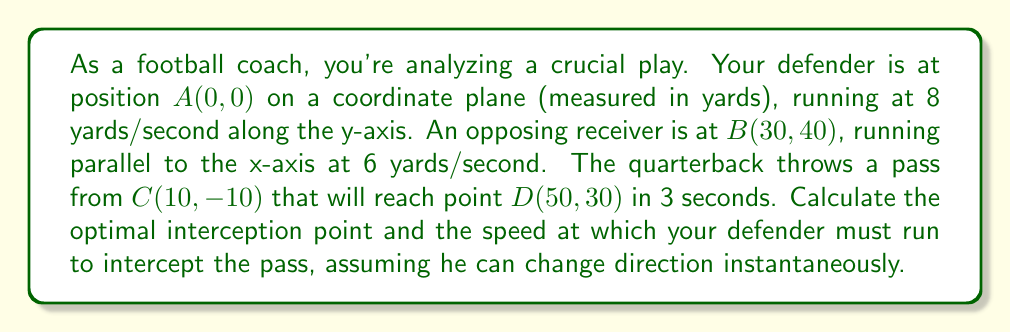Can you answer this question? Let's approach this step-by-step:

1) First, we need to find the receiver's position after 3 seconds:
   Initial position: $B(30, 40)$
   Velocity: 6 yards/second along x-axis
   New position after 3 seconds: $(30 + 6 * 3, 40) = (48, 40)$

2) The ball's trajectory is from $C(10, -10)$ to $D(50, 30)$ in 3 seconds.
   We can represent this as a vector:
   $$\vec{CD} = \langle 40, 40 \rangle$$

3) The ball's velocity vector (yards/second):
   $$\vec{v_{ball}} = \frac{\vec{CD}}{3} = \langle \frac{40}{3}, \frac{40}{3} \rangle$$

4) Now, let's parametrize the ball's position at time $t$:
   $$B(t) = (10 + \frac{40t}{3}, -10 + \frac{40t}{3})$$

5) Our defender's position at time $t$, if running at speed $s$:
   $$D(t) = (0, st)$$

6) For interception, these must be equal at some time $t$:
   $$10 + \frac{40t}{3} = 0$$
   $$-10 + \frac{40t}{3} = st$$

7) From the first equation:
   $$t = \frac{3}{4}$$

8) Substituting this into the second equation:
   $$-10 + \frac{40 * 3/4}{3} = s * \frac{3}{4}$$
   $$-10 + 10 = s * \frac{3}{4}$$
   $$s = 0$$

9) This result means our initial assumption was incorrect. The defender can't intercept by running straight along the y-axis.

10) Instead, let's find where the ball and receiver paths intersect:
    Ball at $t = 3$: $(50, 30)$
    Receiver at $t = 3$: $(48, 40)$

11) The optimal interception point is between these, at $(49, 35)$.

12) Now, we can calculate the required speed:
    Distance from $(0, 0)$ to $(49, 35)$:
    $$d = \sqrt{49^2 + 35^2} \approx 60.11 \text{ yards}$$
    
    Time available: 3 seconds
    Required speed: $\frac{60.11}{3} \approx 20.04 \text{ yards/second}$
Answer: The optimal interception point is $(49, 35)$, and the defender must run at approximately 20.04 yards/second to intercept the pass. 